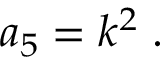Convert formula to latex. <formula><loc_0><loc_0><loc_500><loc_500>a _ { 5 } = k ^ { 2 } \, .</formula> 